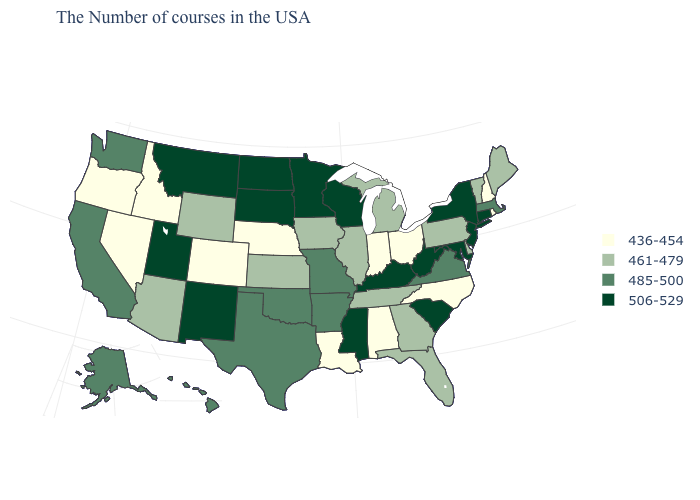What is the lowest value in the USA?
Give a very brief answer. 436-454. How many symbols are there in the legend?
Be succinct. 4. Does the first symbol in the legend represent the smallest category?
Write a very short answer. Yes. Which states have the lowest value in the USA?
Give a very brief answer. Rhode Island, New Hampshire, North Carolina, Ohio, Indiana, Alabama, Louisiana, Nebraska, Colorado, Idaho, Nevada, Oregon. Name the states that have a value in the range 506-529?
Concise answer only. Connecticut, New York, New Jersey, Maryland, South Carolina, West Virginia, Kentucky, Wisconsin, Mississippi, Minnesota, South Dakota, North Dakota, New Mexico, Utah, Montana. Name the states that have a value in the range 436-454?
Be succinct. Rhode Island, New Hampshire, North Carolina, Ohio, Indiana, Alabama, Louisiana, Nebraska, Colorado, Idaho, Nevada, Oregon. Does Wisconsin have the highest value in the USA?
Short answer required. Yes. What is the value of Utah?
Short answer required. 506-529. How many symbols are there in the legend?
Give a very brief answer. 4. Name the states that have a value in the range 485-500?
Give a very brief answer. Massachusetts, Virginia, Missouri, Arkansas, Oklahoma, Texas, California, Washington, Alaska, Hawaii. What is the highest value in the West ?
Keep it brief. 506-529. Does Ohio have a lower value than Colorado?
Answer briefly. No. What is the value of Michigan?
Keep it brief. 461-479. What is the value of Ohio?
Write a very short answer. 436-454. What is the value of Michigan?
Write a very short answer. 461-479. 